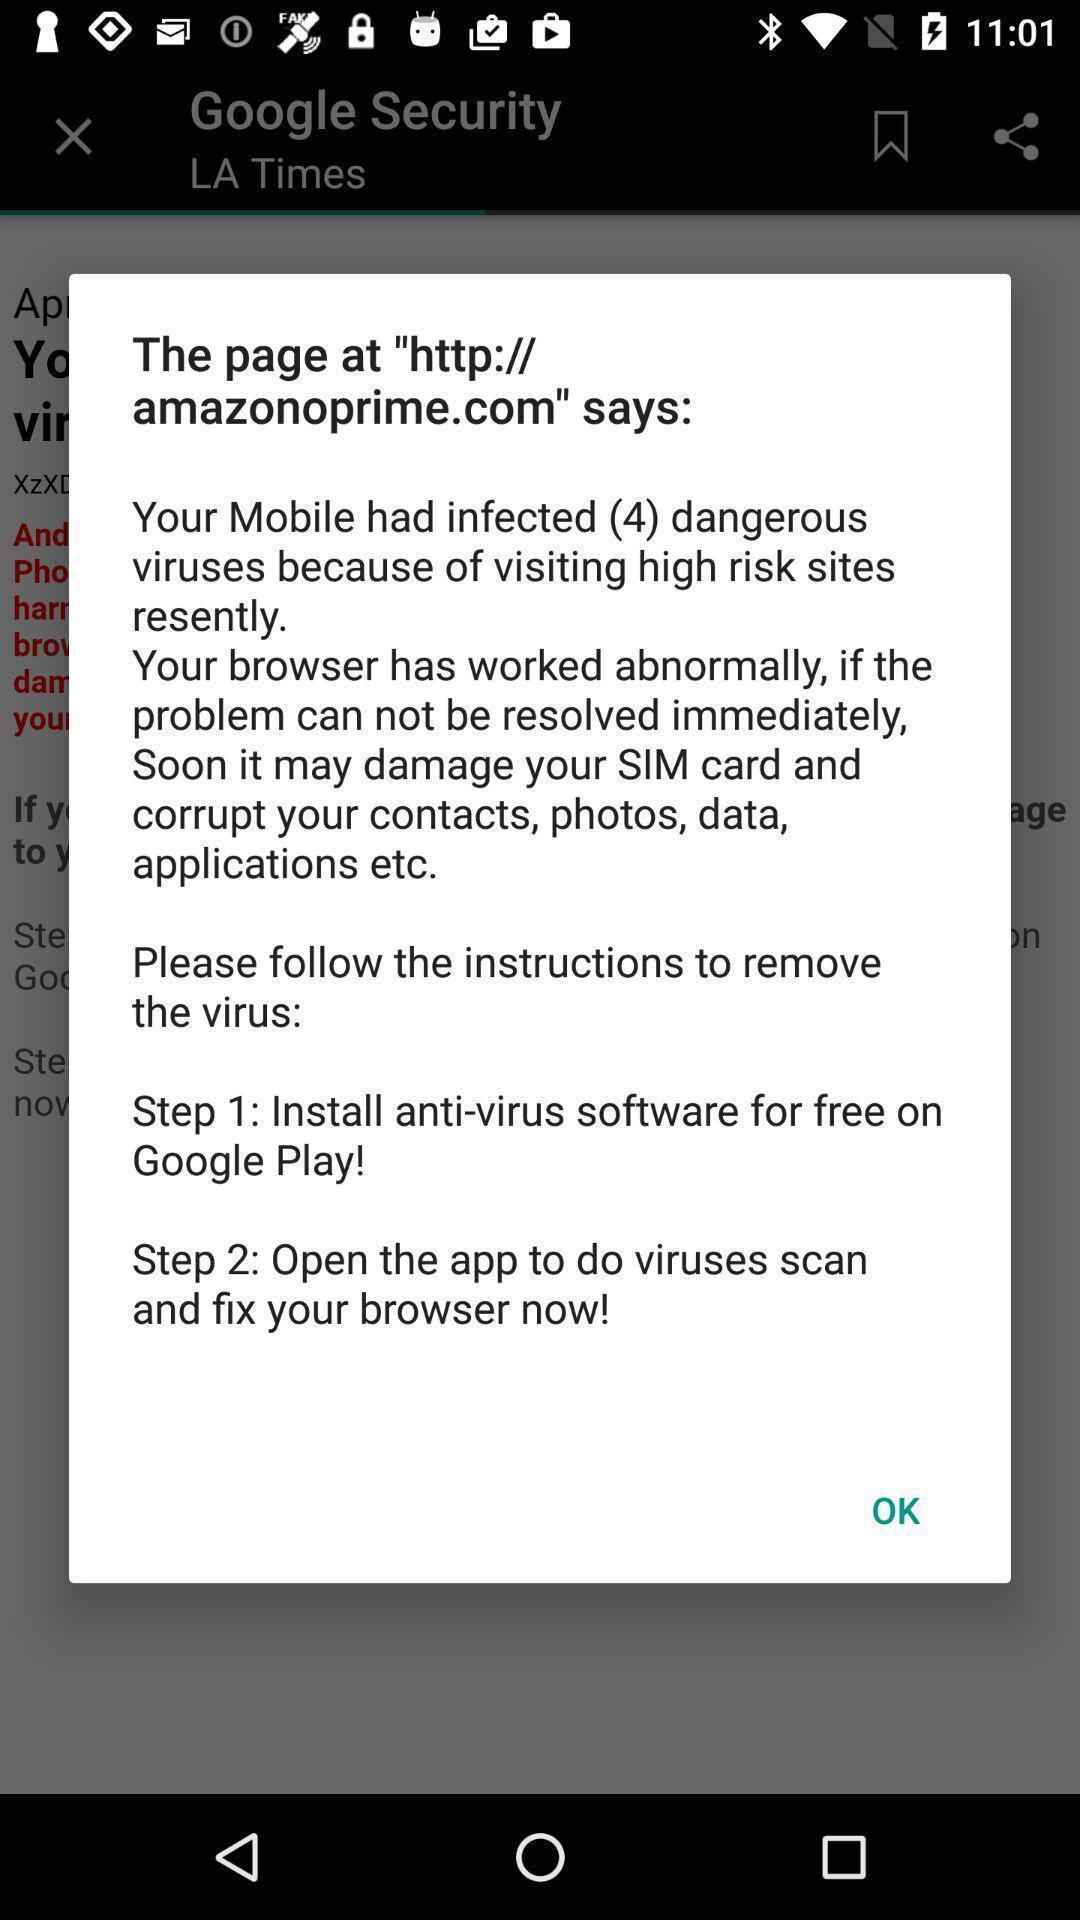Summarize the information in this screenshot. Pop up showing warning on an app. 